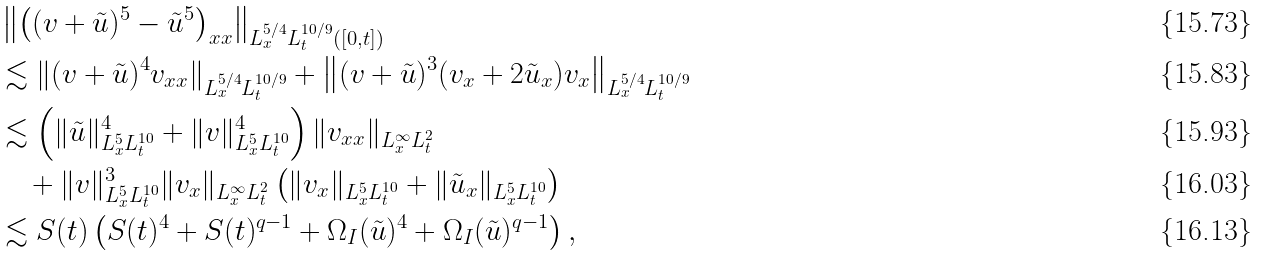<formula> <loc_0><loc_0><loc_500><loc_500>& \left \| \left ( ( v + \tilde { u } ) ^ { 5 } - \tilde { u } ^ { 5 } \right ) _ { x x } \right \| _ { L ^ { 5 / 4 } _ { x } L ^ { 1 0 / 9 } _ { t } ( [ 0 , t ] ) } \\ & \lesssim \| ( v + \tilde { u } ) ^ { 4 } v _ { x x } \| _ { L ^ { 5 / 4 } _ { x } L ^ { 1 0 / 9 } _ { t } } + \left \| ( v + \tilde { u } ) ^ { 3 } ( v _ { x } + 2 \tilde { u } _ { x } ) v _ { x } \right \| _ { L ^ { 5 / 4 } _ { x } L ^ { 1 0 / 9 } _ { t } } \\ & \lesssim \left ( \| \tilde { u } \| ^ { 4 } _ { L ^ { 5 } _ { x } L ^ { 1 0 } _ { t } } + \| v \| ^ { 4 } _ { L ^ { 5 } _ { x } L ^ { 1 0 } _ { t } } \right ) \| v _ { x x } \| _ { L ^ { \infty } _ { x } L ^ { 2 } _ { t } } \\ & \quad + \| v \| ^ { 3 } _ { L ^ { 5 } _ { x } L ^ { 1 0 } _ { t } } \| v _ { x } \| _ { L ^ { \infty } _ { x } L ^ { 2 } _ { t } } \left ( \| v _ { x } \| _ { L ^ { 5 } _ { x } L ^ { 1 0 } _ { t } } + \| \tilde { u } _ { x } \| _ { L ^ { 5 } _ { x } L ^ { 1 0 } _ { t } } \right ) \\ & \lesssim S ( t ) \left ( S ( t ) ^ { 4 } + S ( t ) ^ { q - 1 } + \Omega _ { I } ( \tilde { u } ) ^ { 4 } + \Omega _ { I } ( \tilde { u } ) ^ { q - 1 } \right ) ,</formula> 